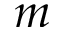Convert formula to latex. <formula><loc_0><loc_0><loc_500><loc_500>m</formula> 